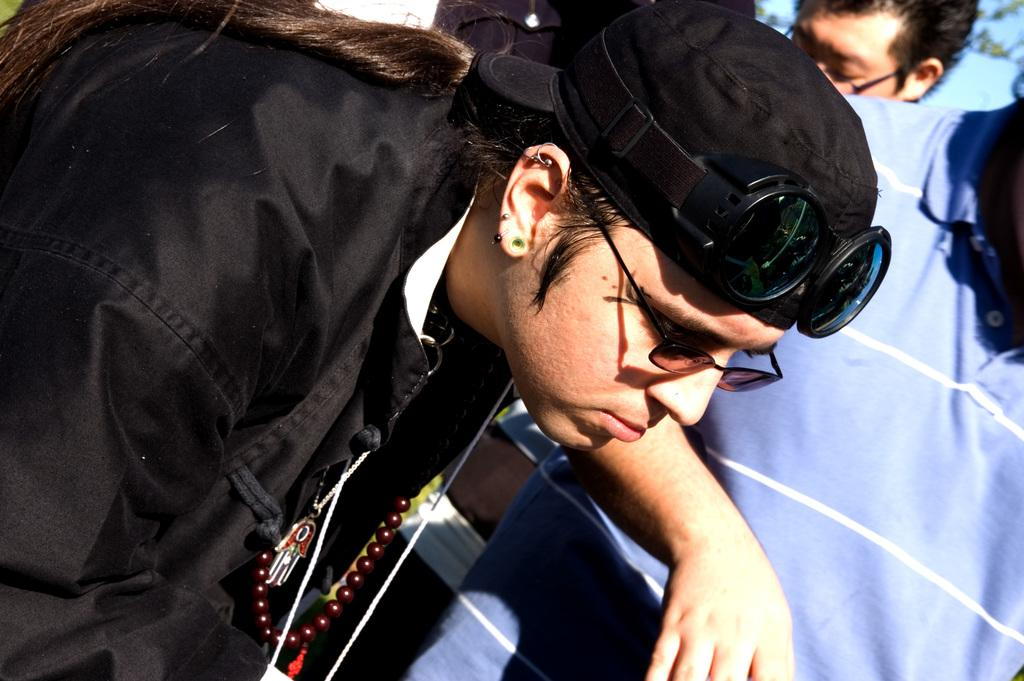How many people are in the image? There are people in the image. Can you describe the attire of one of the people? One person is wearing a cap, goggles, and chains. What might the person wearing the cap, goggles, and chains be doing? It is difficult to determine the exact activity from the image, but the protective gear suggests they might be engaging in a potentially hazardous or high-speed activity. What type of lumber is the person holding in the image? There is no lumber present in the image. Can you tell me what kind of beast the person is riding in the image? There is no beast present in the image. 